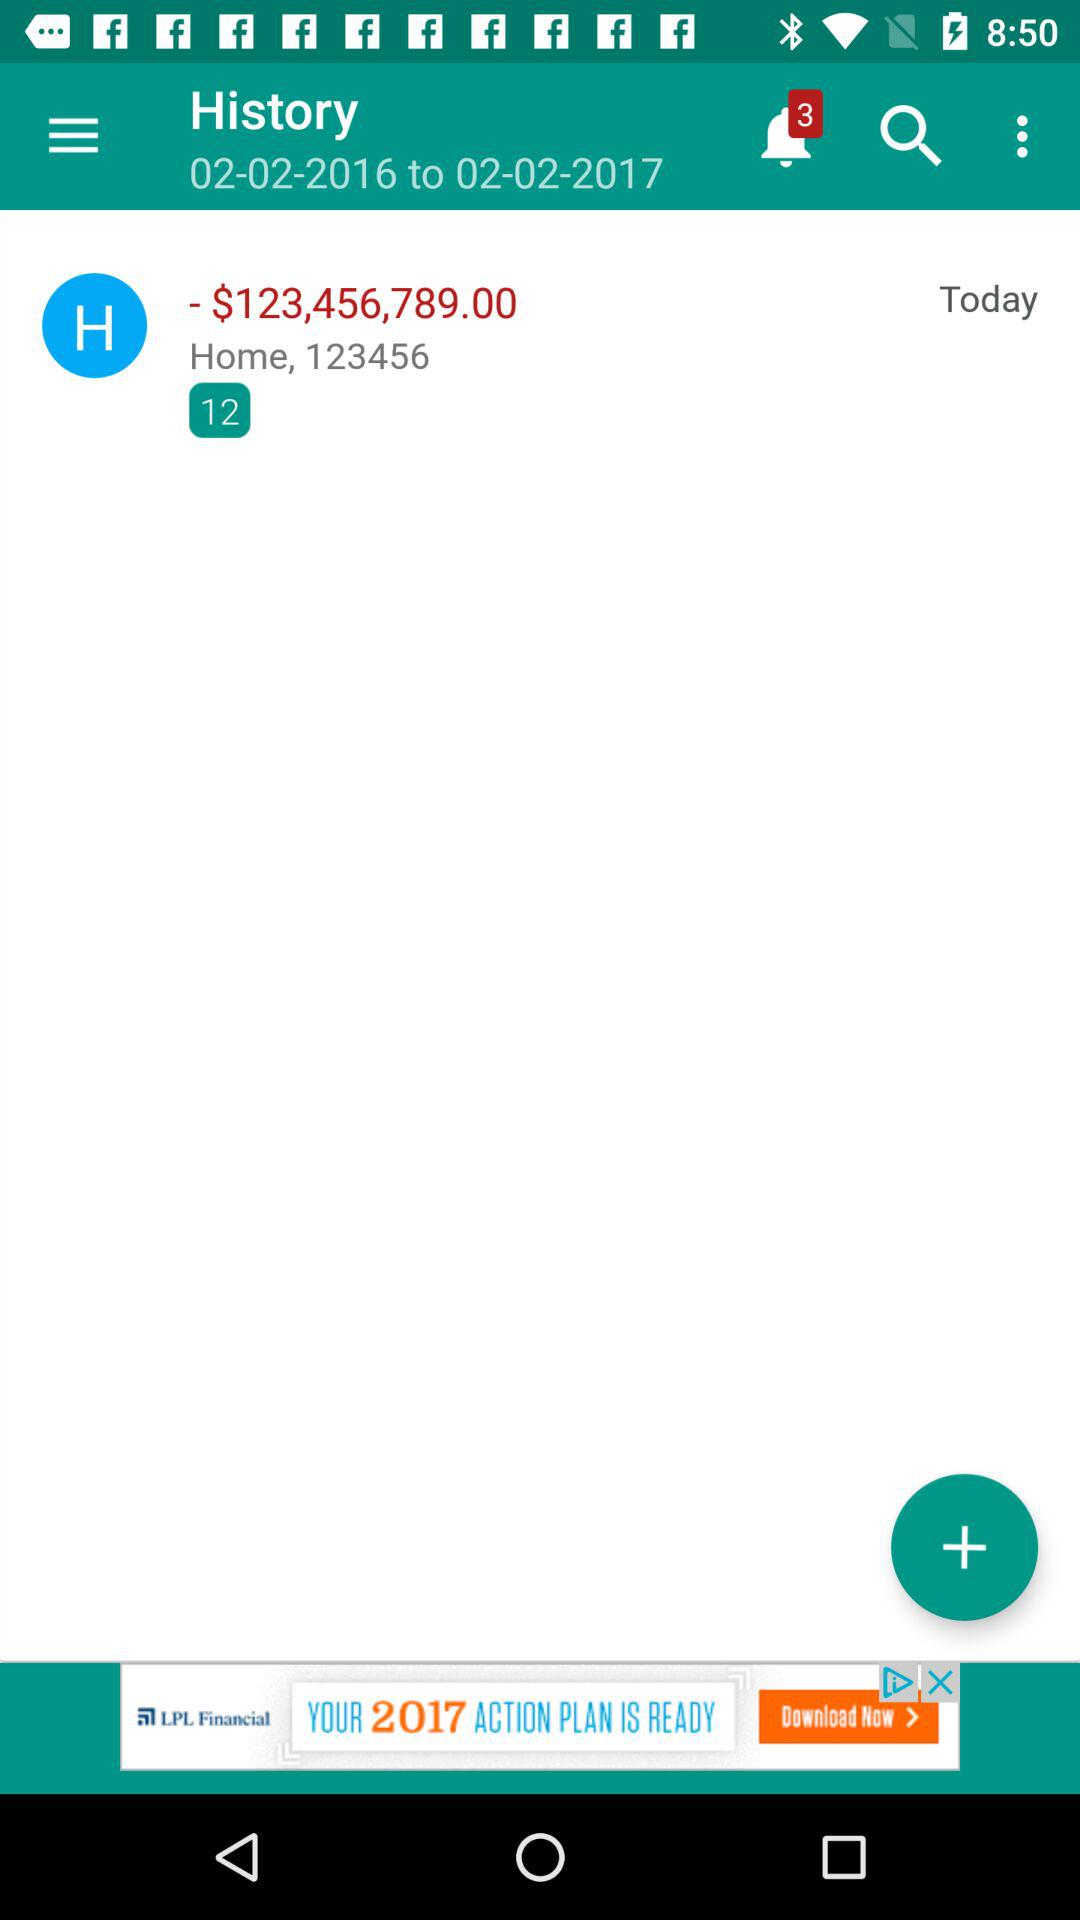What is the amount of money in the account?
Answer the question using a single word or phrase. $123,456,789.00 